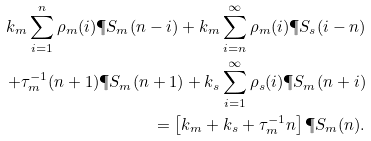<formula> <loc_0><loc_0><loc_500><loc_500>k _ { m } \sum _ { i = 1 } ^ { n } \rho _ { m } ( i ) \P S _ { m } ( n - i ) + k _ { m } \sum _ { i = n } ^ { \infty } \rho _ { m } ( i ) \P S _ { s } ( i - n ) \\ + \tau _ { m } ^ { - 1 } ( n + 1 ) \P S _ { m } ( n + 1 ) + k _ { s } \sum _ { i = 1 } ^ { \infty } \rho _ { s } ( i ) \P S _ { m } ( n + i ) \\ = \left [ k _ { m } + k _ { s } + \tau _ { m } ^ { - 1 } n \right ] \P S _ { m } ( n ) .</formula> 